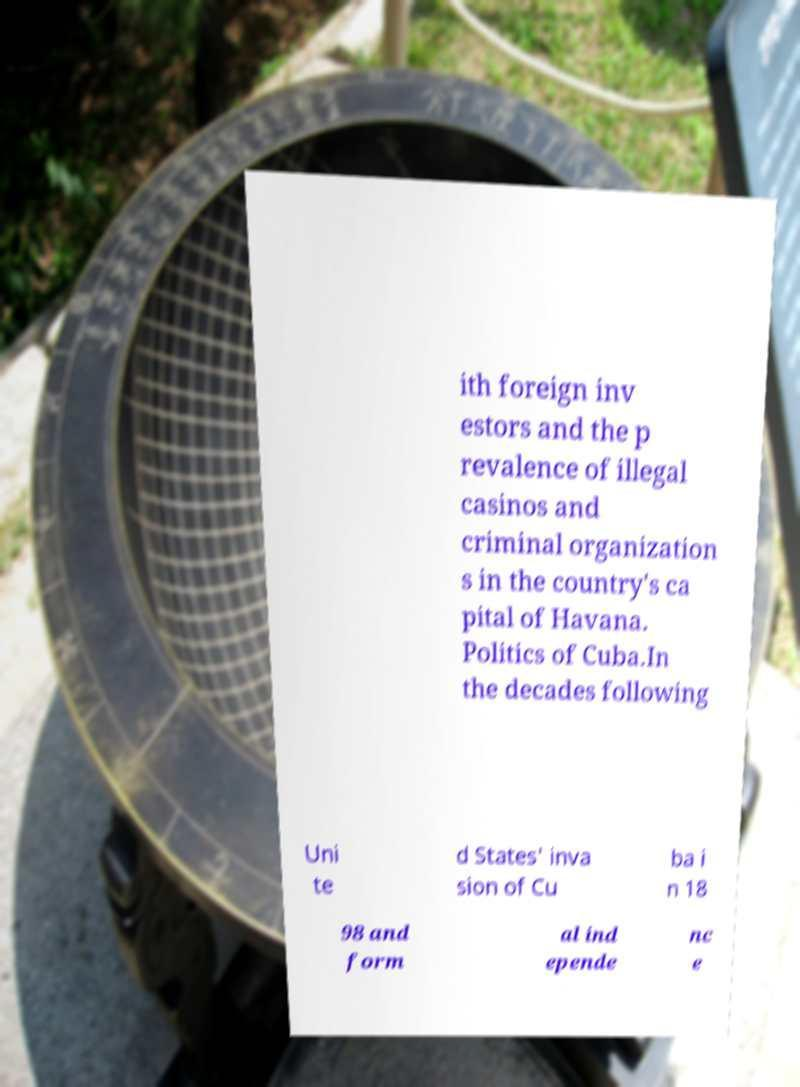Can you read and provide the text displayed in the image?This photo seems to have some interesting text. Can you extract and type it out for me? ith foreign inv estors and the p revalence of illegal casinos and criminal organization s in the country's ca pital of Havana. Politics of Cuba.In the decades following Uni te d States' inva sion of Cu ba i n 18 98 and form al ind epende nc e 